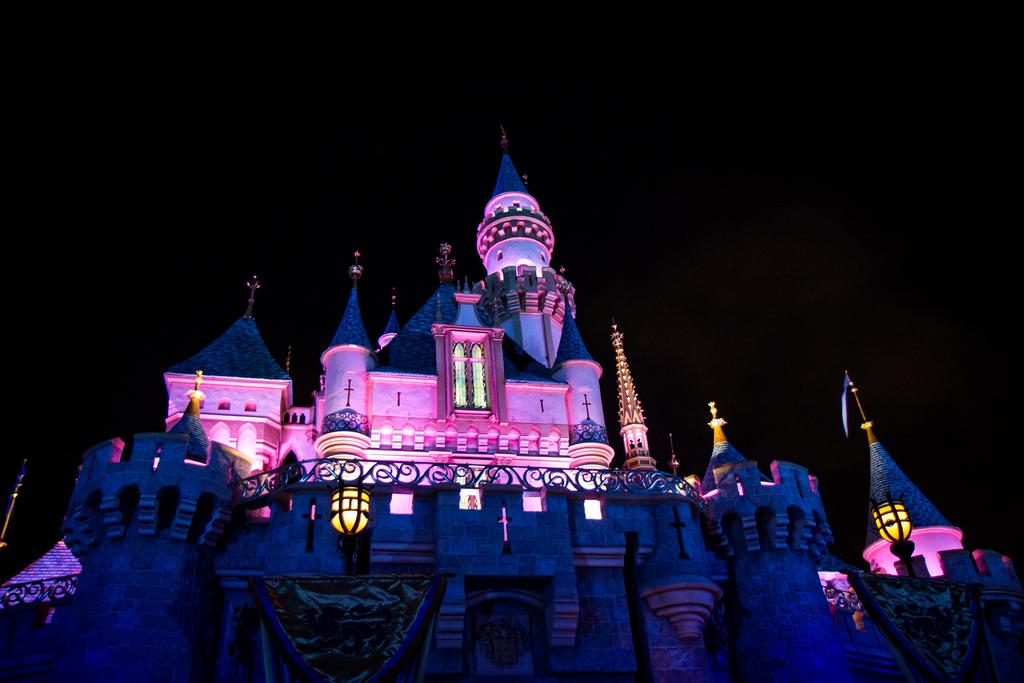What is the main subject of the image? The main subject of the image is a building. What can be seen inside the building? There are lights visible in the building. What is the color of the background in the image? The background of the image is dark. What degree of curvature can be seen in the arm of the person in the image? There is no person present in the image, so it is not possible to determine the curvature of their arm. 